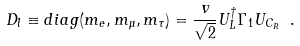<formula> <loc_0><loc_0><loc_500><loc_500>D _ { l } \equiv d i a g ( m _ { e } , m _ { \mu } , m _ { \tau } ) = \frac { v } { \sqrt { 2 } } U _ { L } ^ { \dagger } \Gamma _ { 1 } U _ { C _ { R } } \ .</formula> 